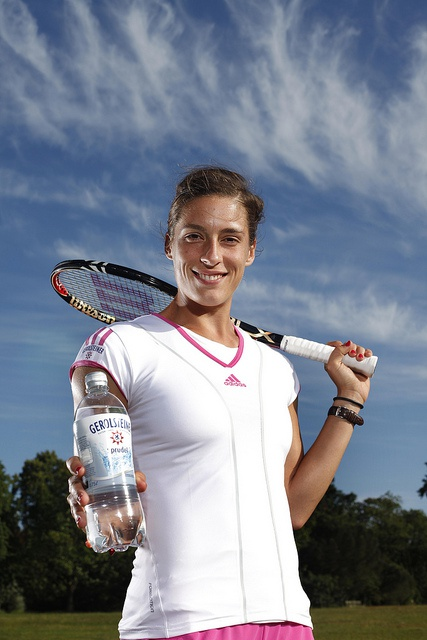Describe the objects in this image and their specific colors. I can see people in gray, white, darkgray, and brown tones, bottle in gray, lightgray, and darkgray tones, and tennis racket in gray, black, and darkgray tones in this image. 